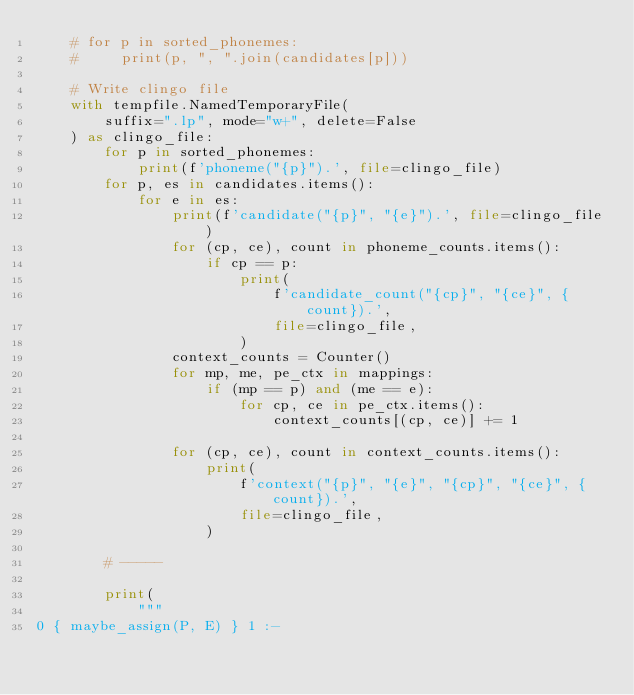Convert code to text. <code><loc_0><loc_0><loc_500><loc_500><_Python_>    # for p in sorted_phonemes:
    #     print(p, ", ".join(candidates[p]))

    # Write clingo file
    with tempfile.NamedTemporaryFile(
        suffix=".lp", mode="w+", delete=False
    ) as clingo_file:
        for p in sorted_phonemes:
            print(f'phoneme("{p}").', file=clingo_file)
        for p, es in candidates.items():
            for e in es:
                print(f'candidate("{p}", "{e}").', file=clingo_file)
                for (cp, ce), count in phoneme_counts.items():
                    if cp == p:
                        print(
                            f'candidate_count("{cp}", "{ce}", {count}).',
                            file=clingo_file,
                        )
                context_counts = Counter()
                for mp, me, pe_ctx in mappings:
                    if (mp == p) and (me == e):
                        for cp, ce in pe_ctx.items():
                            context_counts[(cp, ce)] += 1

                for (cp, ce), count in context_counts.items():
                    print(
                        f'context("{p}", "{e}", "{cp}", "{ce}", {count}).',
                        file=clingo_file,
                    )

        # -----

        print(
            """
0 { maybe_assign(P, E) } 1 :-</code> 